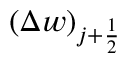Convert formula to latex. <formula><loc_0><loc_0><loc_500><loc_500>\left ( \Delta w \right ) _ { j + \frac { 1 } { 2 } }</formula> 